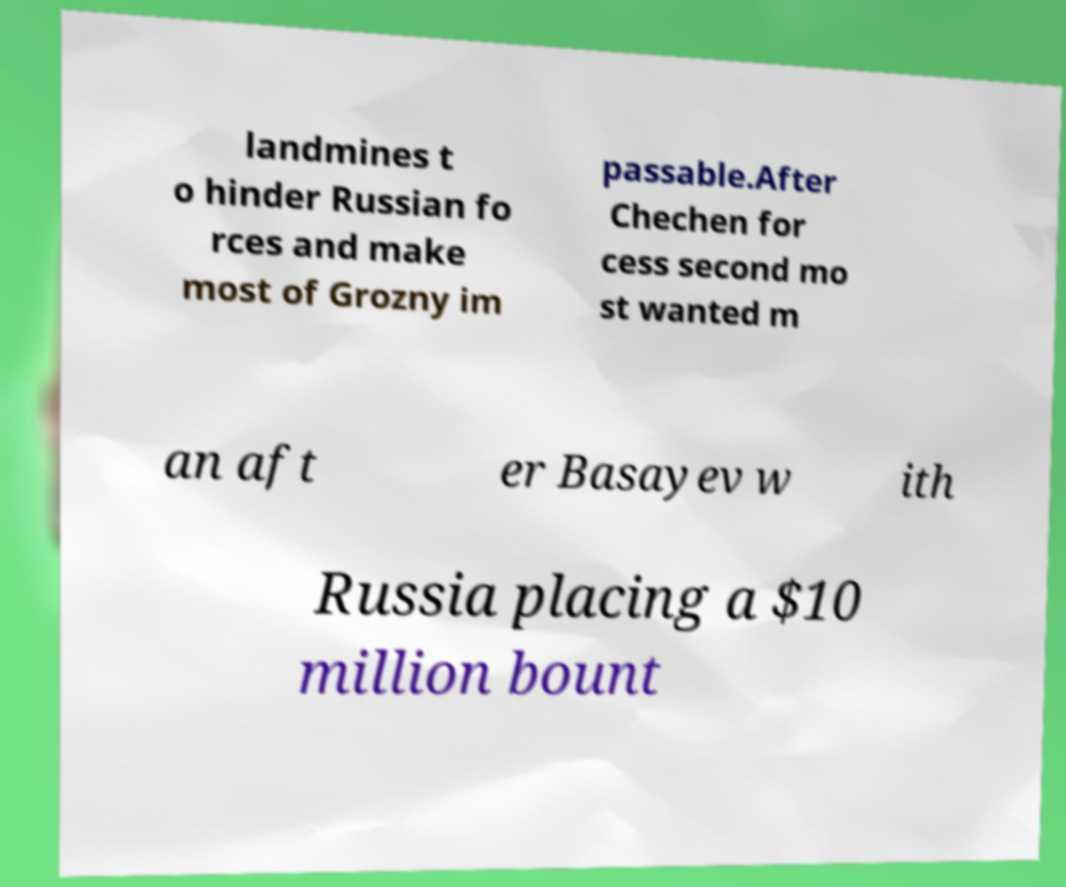Please identify and transcribe the text found in this image. landmines t o hinder Russian fo rces and make most of Grozny im passable.After Chechen for cess second mo st wanted m an aft er Basayev w ith Russia placing a $10 million bount 